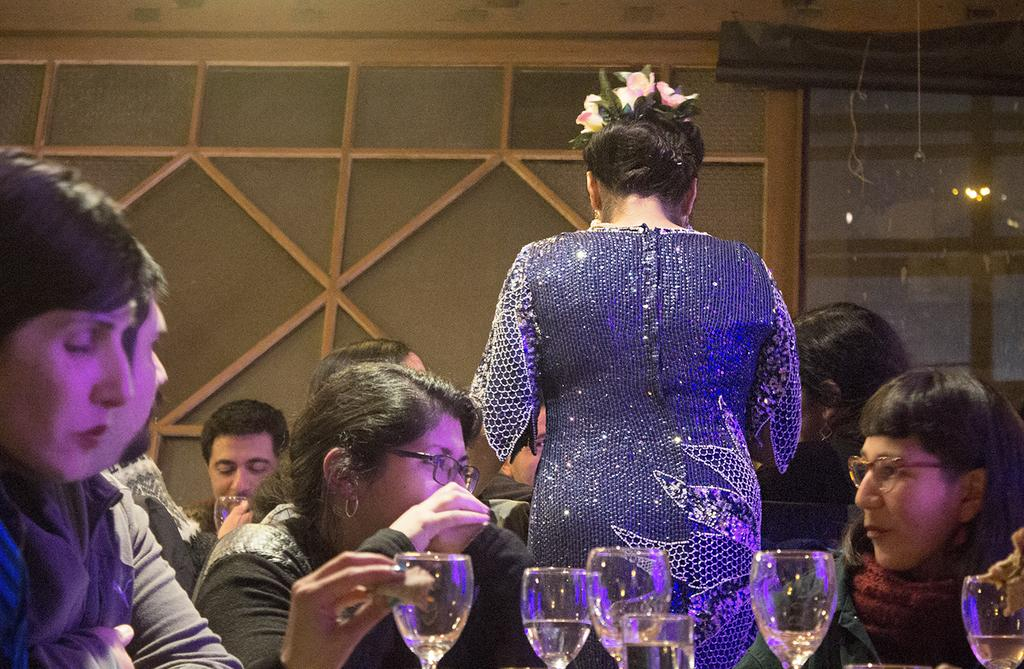How many people are in the image? There is a group of people in the image. What are some of the people in the image doing? Some people are seated, and a woman is standing. What objects are visible in front of the group? There are glasses visible in front of the group. What type of instrument is the woman playing in the image? There is no instrument present in the image, and the woman is not playing any instrument. 